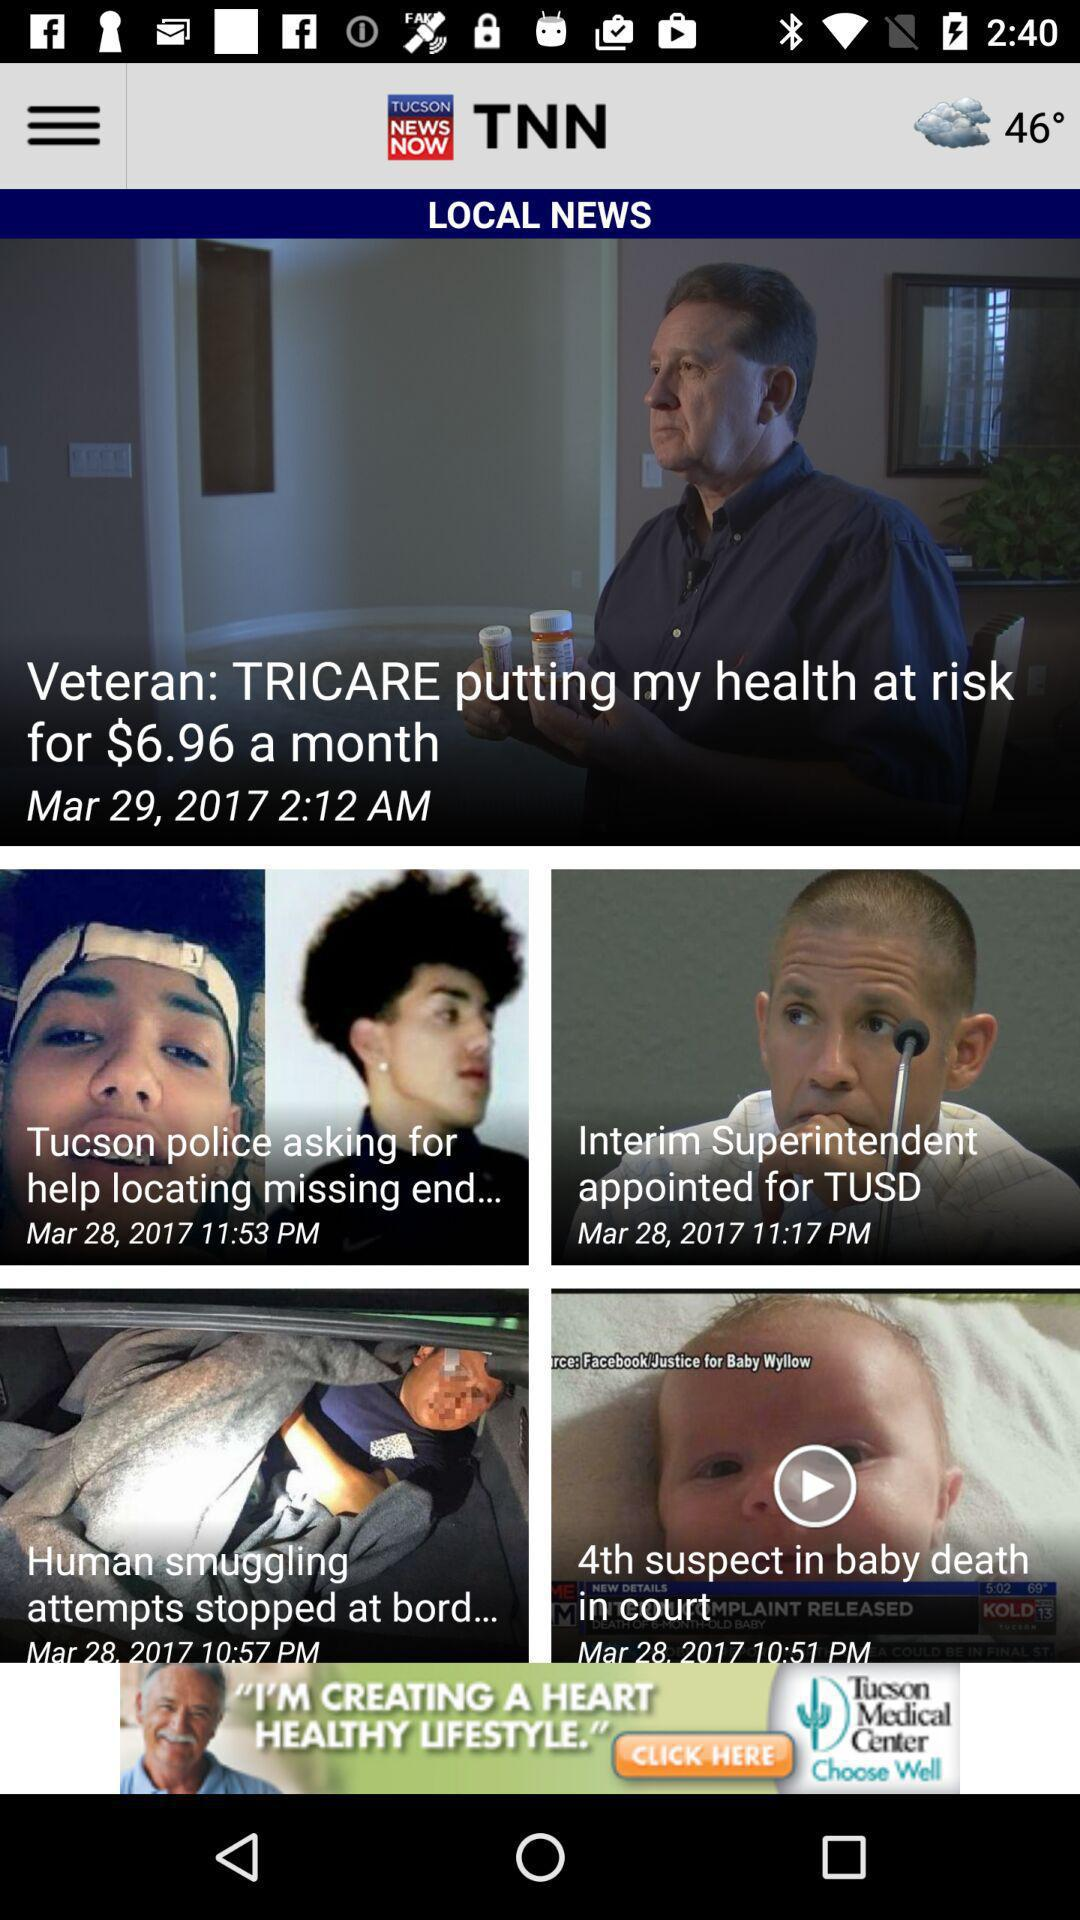What is the weather and temperature? The weather is cloudy and the temperature is 46 degrees. 